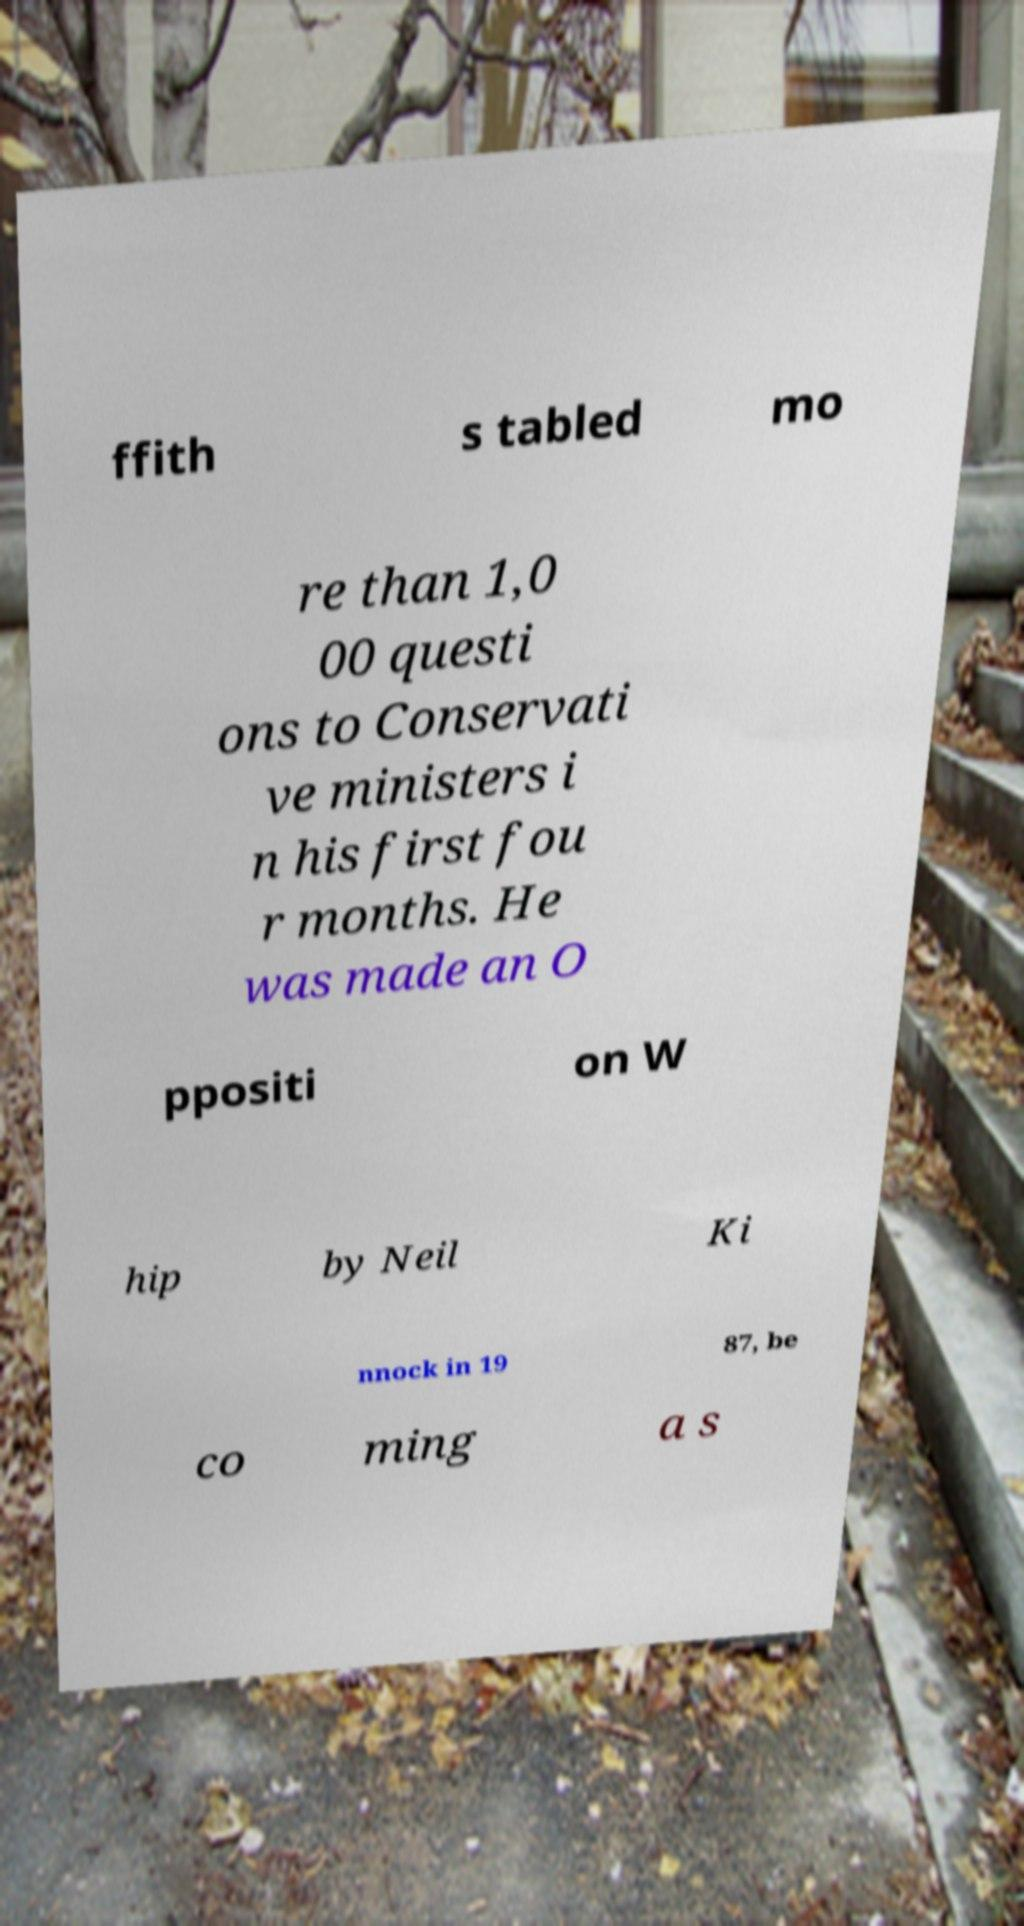Can you read and provide the text displayed in the image?This photo seems to have some interesting text. Can you extract and type it out for me? ffith s tabled mo re than 1,0 00 questi ons to Conservati ve ministers i n his first fou r months. He was made an O ppositi on W hip by Neil Ki nnock in 19 87, be co ming a s 